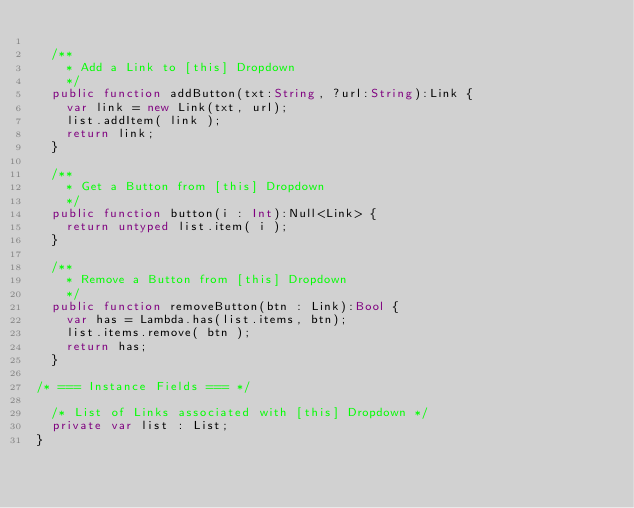Convert code to text. <code><loc_0><loc_0><loc_500><loc_500><_Haxe_>
	/**
	  * Add a Link to [this] Dropdown
	  */
	public function addButton(txt:String, ?url:String):Link {
		var link = new Link(txt, url);
		list.addItem( link );
		return link;
	}

	/**
	  * Get a Button from [this] Dropdown
	  */
	public function button(i : Int):Null<Link> {
		return untyped list.item( i );
	}

	/**
	  * Remove a Button from [this] Dropdown
	  */
	public function removeButton(btn : Link):Bool {
		var has = Lambda.has(list.items, btn);
		list.items.remove( btn );
		return has;
	}

/* === Instance Fields === */

	/* List of Links associated with [this] Dropdown */
	private var list : List;
}
</code> 